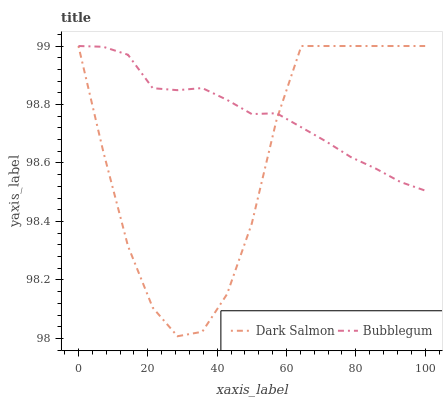Does Dark Salmon have the minimum area under the curve?
Answer yes or no. Yes. Does Bubblegum have the maximum area under the curve?
Answer yes or no. Yes. Does Bubblegum have the minimum area under the curve?
Answer yes or no. No. Is Bubblegum the smoothest?
Answer yes or no. Yes. Is Dark Salmon the roughest?
Answer yes or no. Yes. Is Bubblegum the roughest?
Answer yes or no. No. Does Dark Salmon have the lowest value?
Answer yes or no. Yes. Does Bubblegum have the lowest value?
Answer yes or no. No. Does Bubblegum have the highest value?
Answer yes or no. Yes. Does Dark Salmon intersect Bubblegum?
Answer yes or no. Yes. Is Dark Salmon less than Bubblegum?
Answer yes or no. No. Is Dark Salmon greater than Bubblegum?
Answer yes or no. No. 